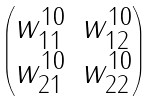<formula> <loc_0><loc_0><loc_500><loc_500>\begin{pmatrix} w ^ { 1 0 } _ { 1 1 } & w ^ { 1 0 } _ { 1 2 } \\ w ^ { 1 0 } _ { 2 1 } & w ^ { 1 0 } _ { 2 2 } \end{pmatrix}</formula> 